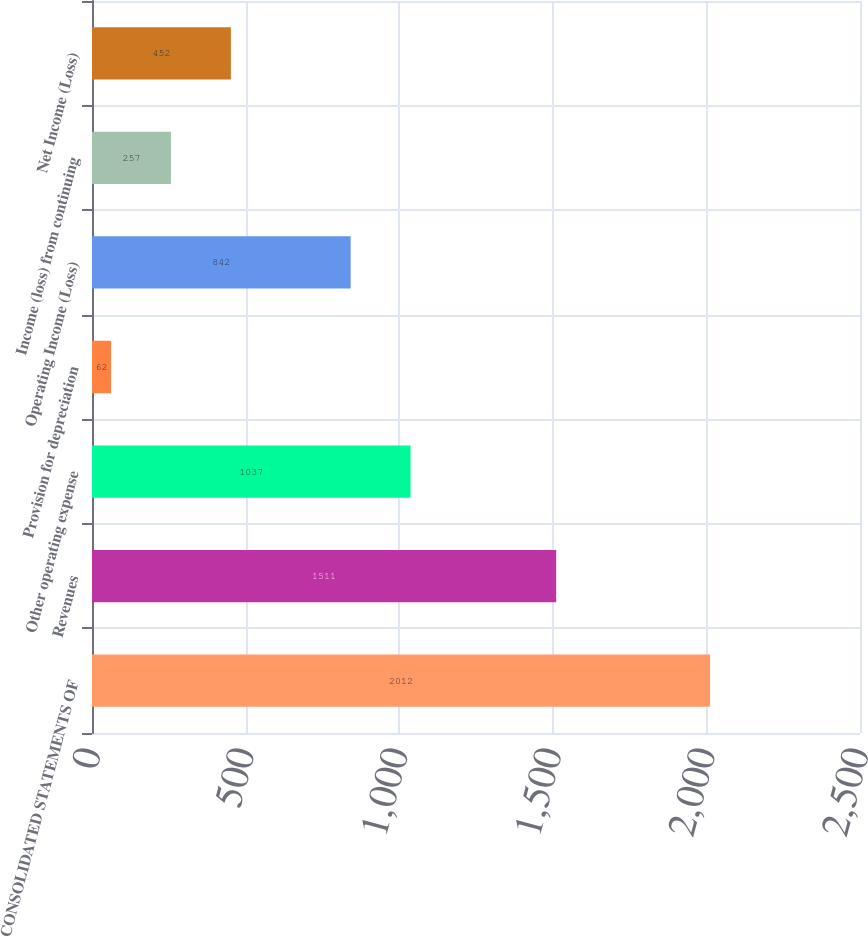Convert chart. <chart><loc_0><loc_0><loc_500><loc_500><bar_chart><fcel>CONSOLIDATED STATEMENTS OF<fcel>Revenues<fcel>Other operating expense<fcel>Provision for depreciation<fcel>Operating Income (Loss)<fcel>Income (loss) from continuing<fcel>Net Income (Loss)<nl><fcel>2012<fcel>1511<fcel>1037<fcel>62<fcel>842<fcel>257<fcel>452<nl></chart> 